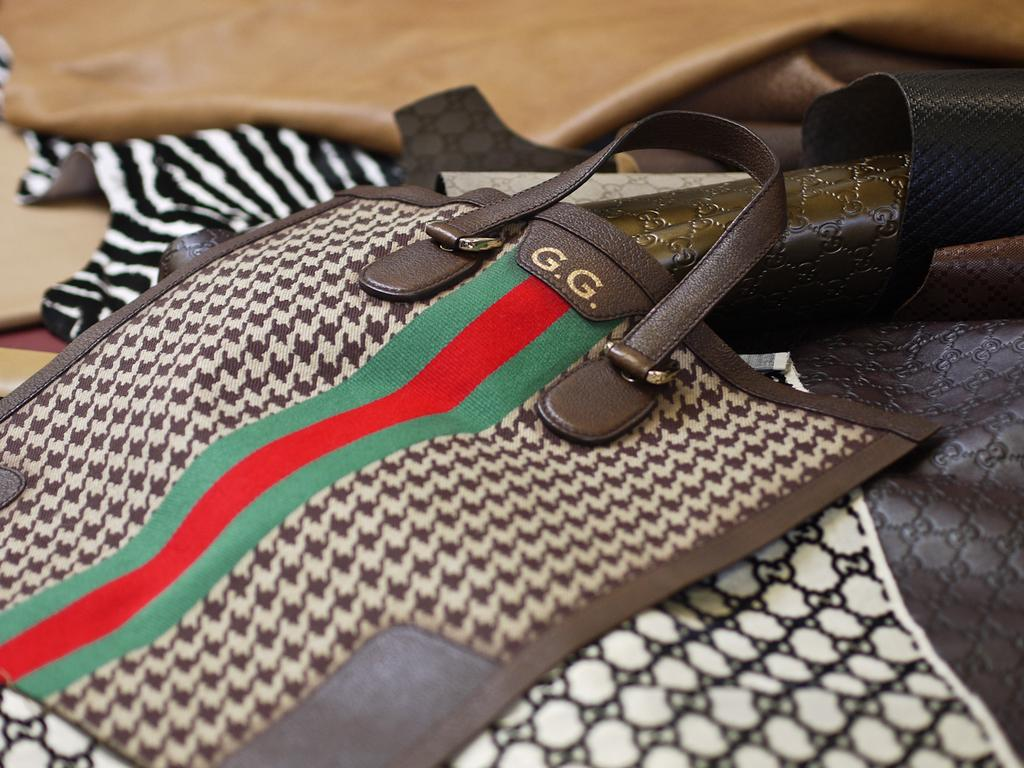What object can be seen in the image? There is a bag in the image. Is there any text or lettering on the bag? Yes, the letter "g" is written on the bag. How many ladybugs are crawling on the bag in the image? There are no ladybugs present in the image. What is the plot of the story depicted in the image? There is no story depicted in the image, as it only features a bag with the letter "g" written on it. 